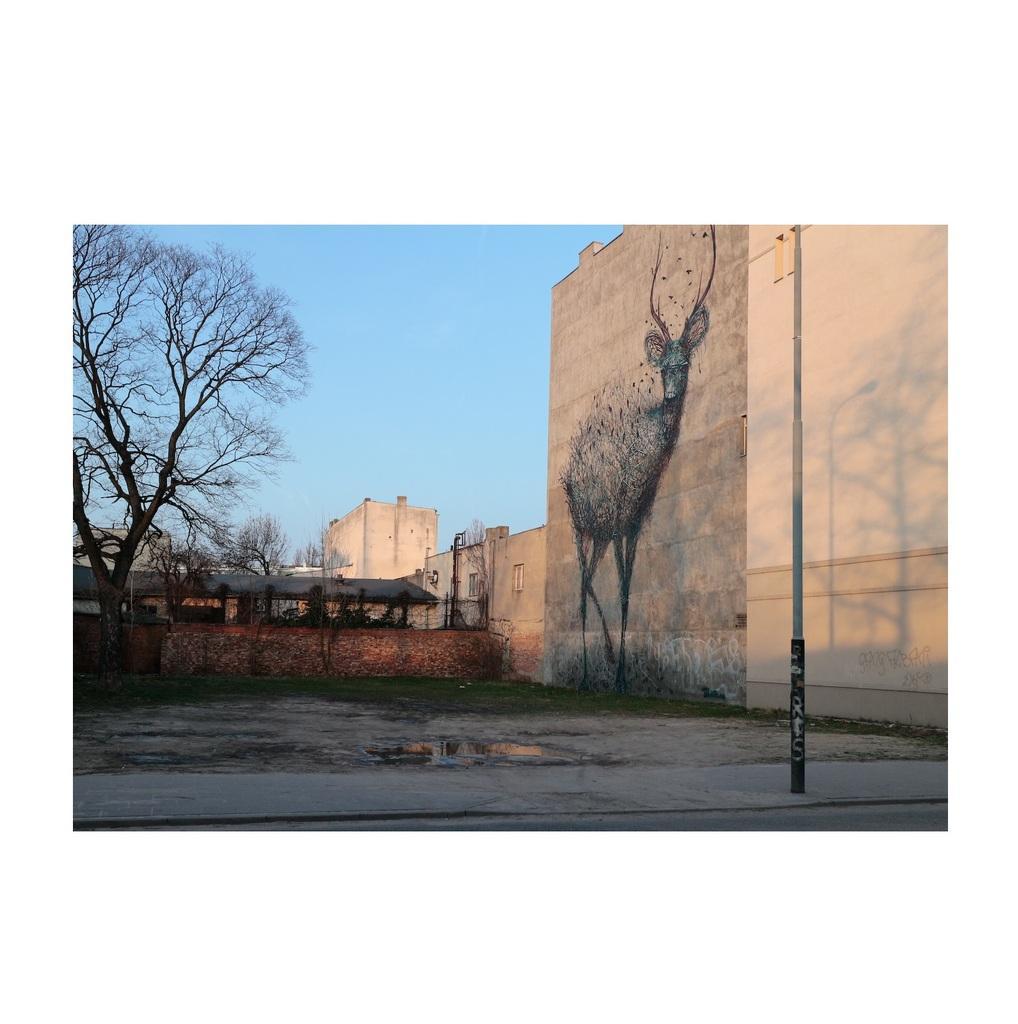Can you describe this image briefly? In this image, we can see the wall with some art. We can see the ground and a pole. We can see some grass and houses. There are a few trees. We can also see the sky. 